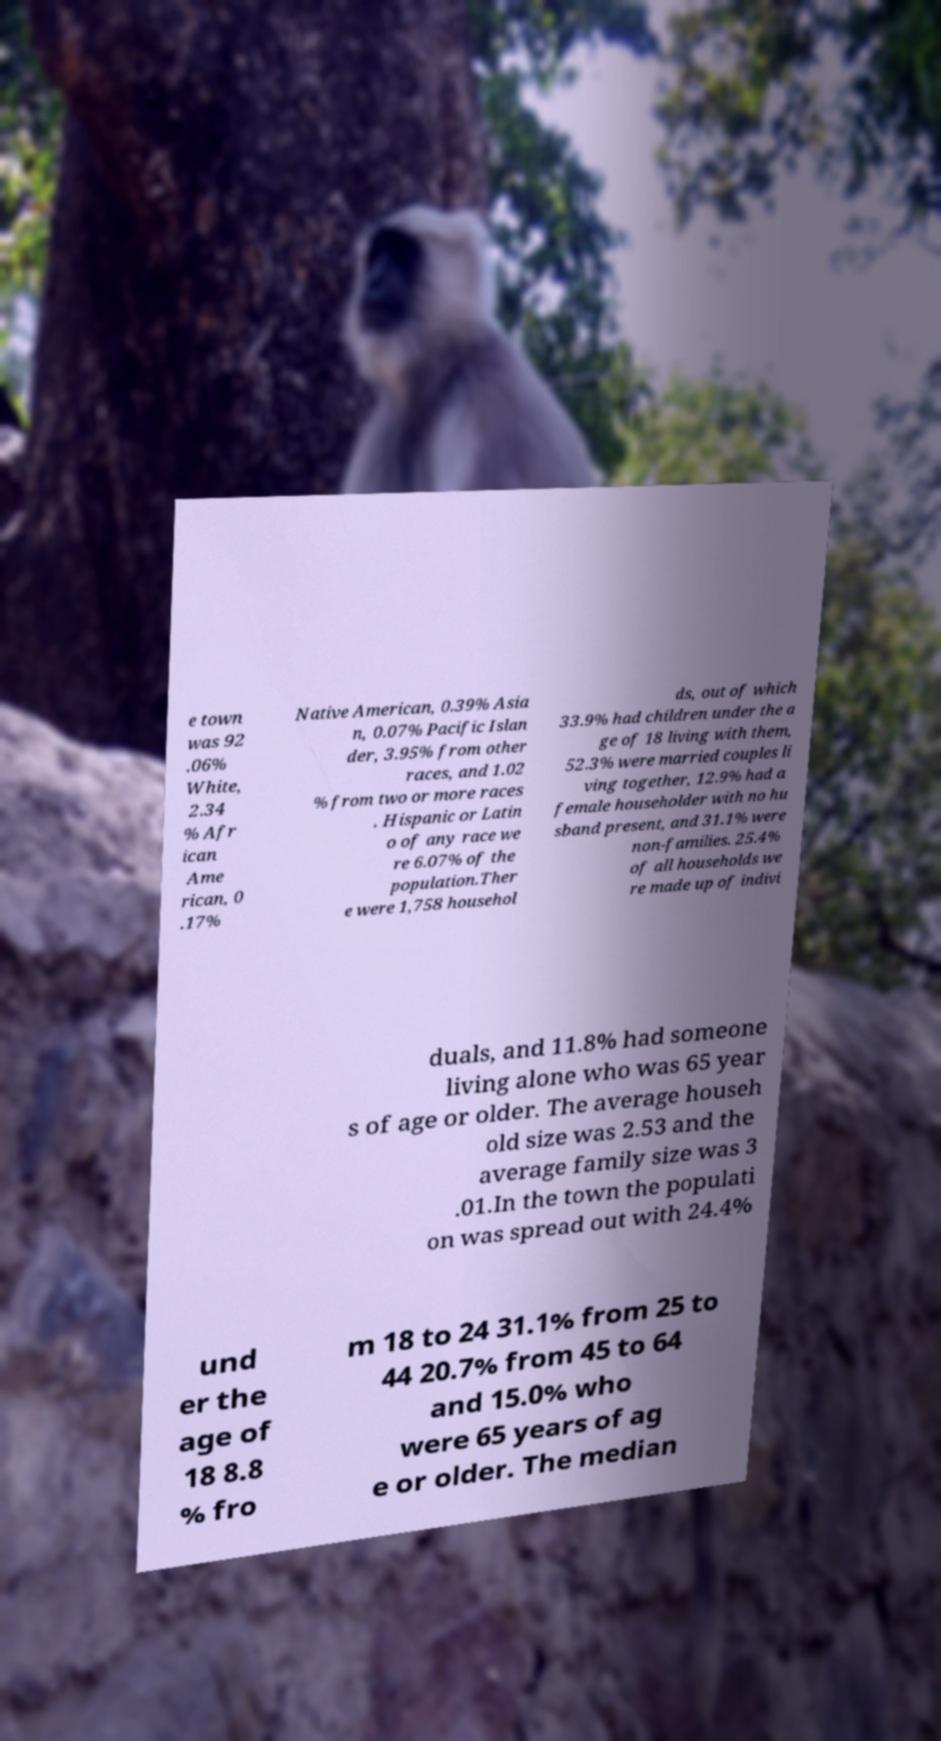I need the written content from this picture converted into text. Can you do that? e town was 92 .06% White, 2.34 % Afr ican Ame rican, 0 .17% Native American, 0.39% Asia n, 0.07% Pacific Islan der, 3.95% from other races, and 1.02 % from two or more races . Hispanic or Latin o of any race we re 6.07% of the population.Ther e were 1,758 househol ds, out of which 33.9% had children under the a ge of 18 living with them, 52.3% were married couples li ving together, 12.9% had a female householder with no hu sband present, and 31.1% were non-families. 25.4% of all households we re made up of indivi duals, and 11.8% had someone living alone who was 65 year s of age or older. The average househ old size was 2.53 and the average family size was 3 .01.In the town the populati on was spread out with 24.4% und er the age of 18 8.8 % fro m 18 to 24 31.1% from 25 to 44 20.7% from 45 to 64 and 15.0% who were 65 years of ag e or older. The median 